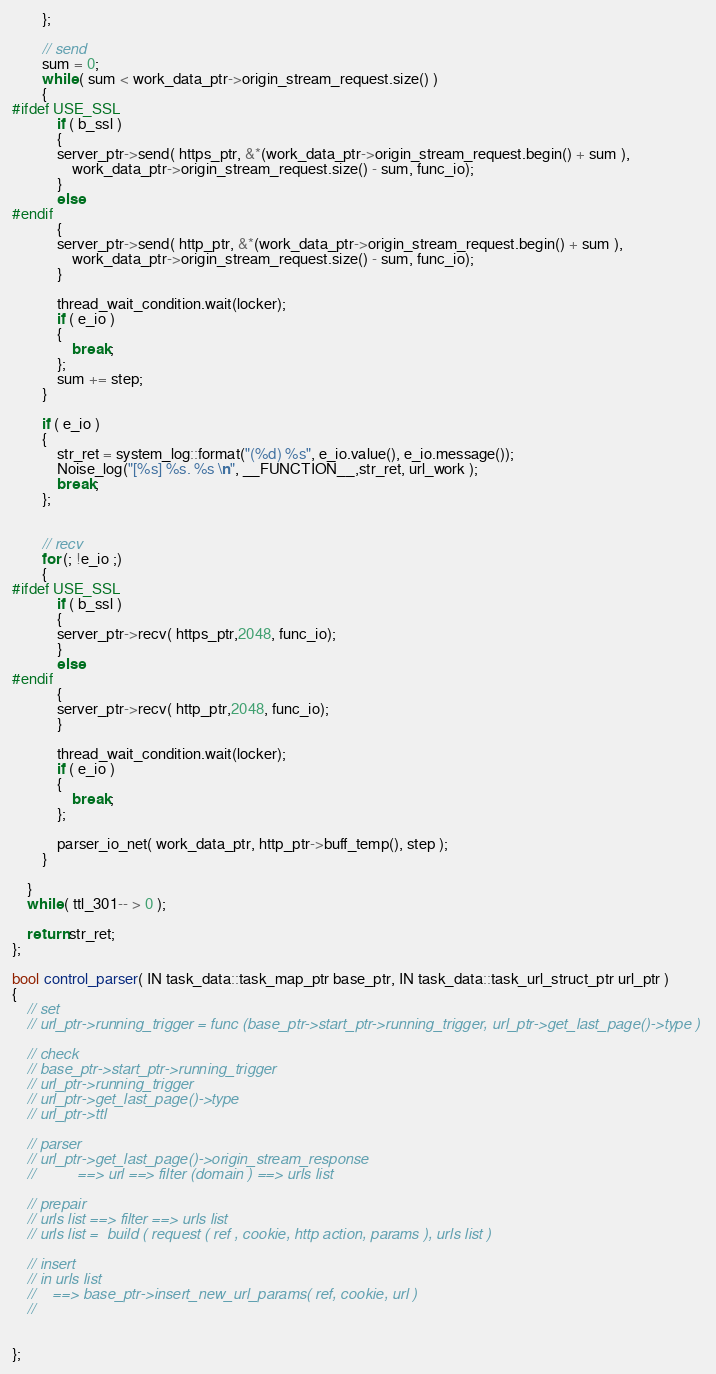Convert code to text. <code><loc_0><loc_0><loc_500><loc_500><_C++_>		};

		// send 
		sum = 0;
		while ( sum < work_data_ptr->origin_stream_request.size() )
		{
#ifdef USE_SSL
			if ( b_ssl )
			{
			server_ptr->send( https_ptr, &*(work_data_ptr->origin_stream_request.begin() + sum ),
				work_data_ptr->origin_stream_request.size() - sum, func_io);
			}
			else
#endif
			{
			server_ptr->send( http_ptr, &*(work_data_ptr->origin_stream_request.begin() + sum ),
				work_data_ptr->origin_stream_request.size() - sum, func_io);
			}

			thread_wait_condition.wait(locker);
			if ( e_io )
			{
				break;
			};
			sum += step;
		}

		if ( e_io )
		{
			str_ret = system_log::format("(%d) %s", e_io.value(), e_io.message());
			Noise_log("[%s] %s. %s \n", __FUNCTION__,str_ret, url_work );
			break;
		};

		
		// recv
		for (; !e_io ;)
		{
#ifdef USE_SSL
			if ( b_ssl )
			{
			server_ptr->recv( https_ptr,2048, func_io);
			}
			else
#endif
			{
			server_ptr->recv( http_ptr,2048, func_io);
			}

			thread_wait_condition.wait(locker);
			if ( e_io )
			{
				break;
			};

			parser_io_net( work_data_ptr, http_ptr->buff_temp(), step );
		}

	}
	while ( ttl_301-- > 0 );

	return str_ret;
};

bool control_parser( IN task_data::task_map_ptr base_ptr, IN task_data::task_url_struct_ptr url_ptr )
{
	// set
	// url_ptr->running_trigger = func (base_ptr->start_ptr->running_trigger, url_ptr->get_last_page()->type )
	
	// check
	// base_ptr->start_ptr->running_trigger
	// url_ptr->running_trigger
	// url_ptr->get_last_page()->type
	// url_ptr->ttl

	// parser
	// url_ptr->get_last_page()->origin_stream_response
	//          ==> url ==> filter (domain ) ==> urls list

	// prepair
	// urls list ==> filter ==> urls list
	// urls list =  build ( request ( ref , cookie, http action, params ), urls list )
	
	// insert 
	// in urls list
	//    ==> base_ptr->insert_new_url_params( ref, cookie, url )
	//


};</code> 